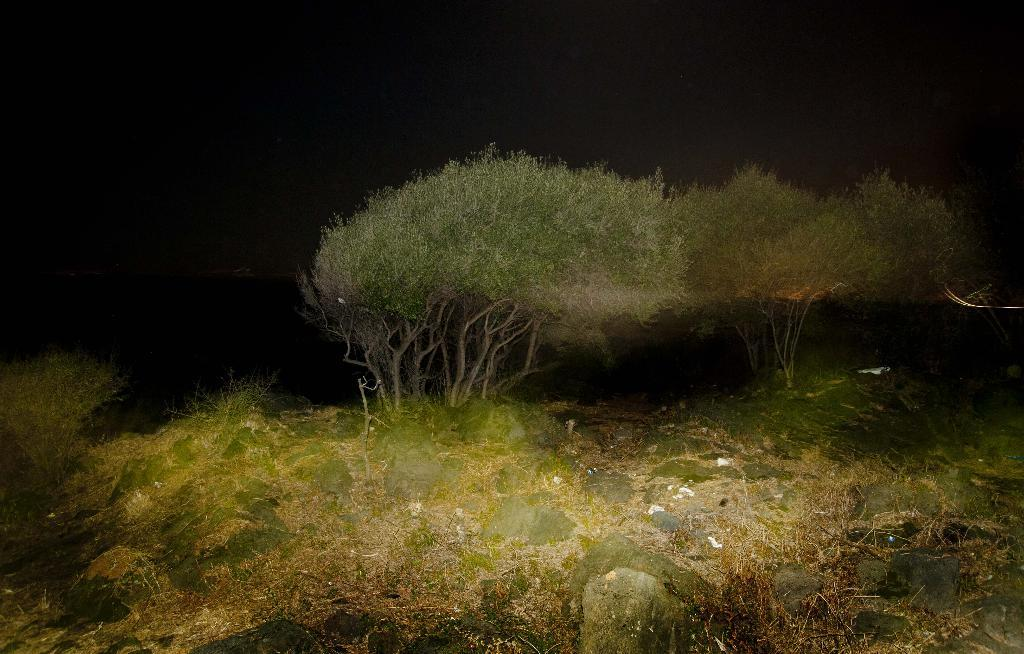What type of terrain is visible in the image? There is ground visible in the image, and there are rocks on the ground. What other natural elements can be seen in the image? There is grass and trees in the image. What is visible in the background of the image? The sky is visible in the background of the image, and it appears to be dark. Who is the owner of the door in the image? There is no door present in the image, so it is not possible to determine the owner. 